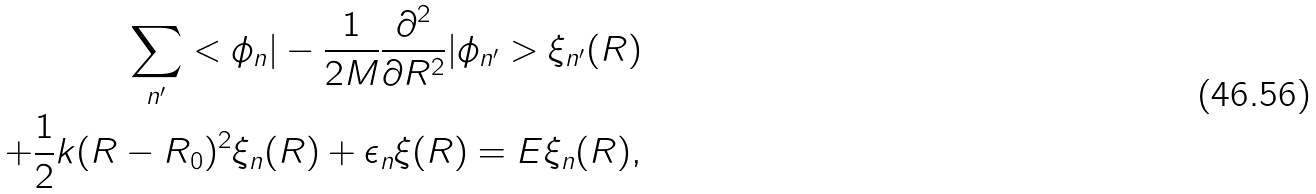Convert formula to latex. <formula><loc_0><loc_0><loc_500><loc_500>\sum _ { n ^ { \prime } } < \phi _ { n } | - \frac { 1 } { 2 M } \frac { \partial ^ { 2 } } { \partial R ^ { 2 } } | \phi _ { n ^ { \prime } } > \xi _ { n ^ { \prime } } ( R ) \\ + \frac { 1 } { 2 } k ( R - R _ { 0 } ) ^ { 2 } \xi _ { n } ( R ) + \epsilon _ { n } \xi ( R ) = E \xi _ { n } ( R ) ,</formula> 